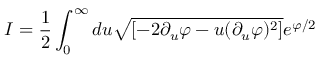Convert formula to latex. <formula><loc_0><loc_0><loc_500><loc_500>I = \frac { 1 } { 2 } \int _ { 0 } ^ { \infty } d u \sqrt { [ - 2 \partial _ { u } \varphi - u ( \partial _ { u } \varphi ) ^ { 2 } ] } e ^ { \varphi / 2 }</formula> 